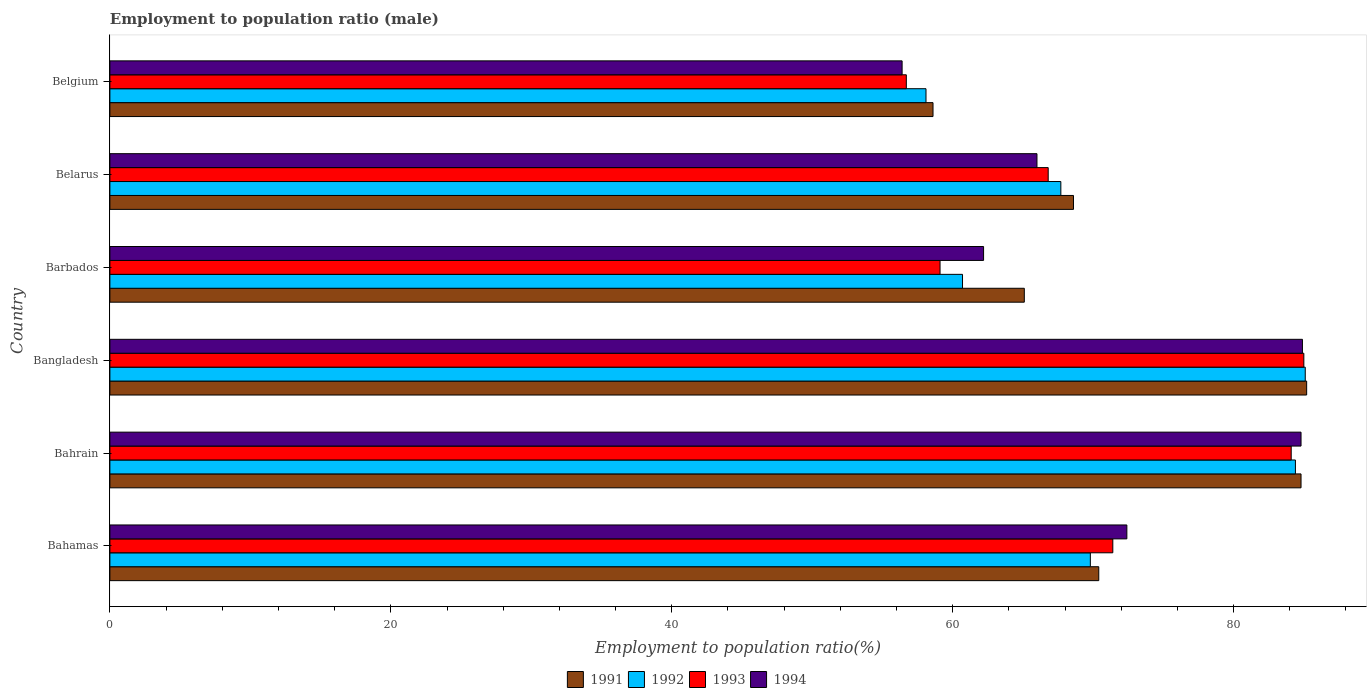How many groups of bars are there?
Provide a short and direct response. 6. Are the number of bars per tick equal to the number of legend labels?
Provide a succinct answer. Yes. How many bars are there on the 2nd tick from the top?
Provide a short and direct response. 4. What is the employment to population ratio in 1993 in Barbados?
Provide a short and direct response. 59.1. Across all countries, what is the maximum employment to population ratio in 1991?
Keep it short and to the point. 85.2. Across all countries, what is the minimum employment to population ratio in 1992?
Your response must be concise. 58.1. What is the total employment to population ratio in 1993 in the graph?
Your answer should be very brief. 423.1. What is the difference between the employment to population ratio in 1993 in Bahamas and that in Bahrain?
Provide a short and direct response. -12.7. What is the difference between the employment to population ratio in 1991 in Bahrain and the employment to population ratio in 1992 in Belgium?
Offer a very short reply. 26.7. What is the average employment to population ratio in 1993 per country?
Your answer should be compact. 70.52. What is the difference between the employment to population ratio in 1992 and employment to population ratio in 1993 in Belgium?
Provide a succinct answer. 1.4. In how many countries, is the employment to population ratio in 1991 greater than 32 %?
Provide a succinct answer. 6. What is the ratio of the employment to population ratio in 1992 in Bangladesh to that in Belgium?
Your answer should be very brief. 1.46. Is the employment to population ratio in 1991 in Bahamas less than that in Barbados?
Your answer should be very brief. No. Is the difference between the employment to population ratio in 1992 in Bahrain and Bangladesh greater than the difference between the employment to population ratio in 1993 in Bahrain and Bangladesh?
Make the answer very short. Yes. What is the difference between the highest and the second highest employment to population ratio in 1991?
Your answer should be very brief. 0.4. What is the difference between the highest and the lowest employment to population ratio in 1993?
Offer a very short reply. 28.3. In how many countries, is the employment to population ratio in 1991 greater than the average employment to population ratio in 1991 taken over all countries?
Provide a short and direct response. 2. Is it the case that in every country, the sum of the employment to population ratio in 1993 and employment to population ratio in 1991 is greater than the sum of employment to population ratio in 1992 and employment to population ratio in 1994?
Your response must be concise. No. What does the 1st bar from the top in Belgium represents?
Offer a terse response. 1994. What does the 2nd bar from the bottom in Belgium represents?
Your answer should be very brief. 1992. Is it the case that in every country, the sum of the employment to population ratio in 1994 and employment to population ratio in 1993 is greater than the employment to population ratio in 1992?
Offer a very short reply. Yes. How many bars are there?
Provide a succinct answer. 24. Does the graph contain any zero values?
Keep it short and to the point. No. Where does the legend appear in the graph?
Provide a succinct answer. Bottom center. How are the legend labels stacked?
Keep it short and to the point. Horizontal. What is the title of the graph?
Your response must be concise. Employment to population ratio (male). Does "1993" appear as one of the legend labels in the graph?
Your answer should be very brief. Yes. What is the label or title of the Y-axis?
Offer a terse response. Country. What is the Employment to population ratio(%) of 1991 in Bahamas?
Your response must be concise. 70.4. What is the Employment to population ratio(%) of 1992 in Bahamas?
Provide a short and direct response. 69.8. What is the Employment to population ratio(%) in 1993 in Bahamas?
Keep it short and to the point. 71.4. What is the Employment to population ratio(%) in 1994 in Bahamas?
Ensure brevity in your answer.  72.4. What is the Employment to population ratio(%) in 1991 in Bahrain?
Offer a very short reply. 84.8. What is the Employment to population ratio(%) in 1992 in Bahrain?
Your response must be concise. 84.4. What is the Employment to population ratio(%) of 1993 in Bahrain?
Your answer should be compact. 84.1. What is the Employment to population ratio(%) of 1994 in Bahrain?
Your answer should be compact. 84.8. What is the Employment to population ratio(%) of 1991 in Bangladesh?
Your response must be concise. 85.2. What is the Employment to population ratio(%) in 1992 in Bangladesh?
Offer a very short reply. 85.1. What is the Employment to population ratio(%) in 1994 in Bangladesh?
Give a very brief answer. 84.9. What is the Employment to population ratio(%) in 1991 in Barbados?
Your answer should be very brief. 65.1. What is the Employment to population ratio(%) in 1992 in Barbados?
Your answer should be very brief. 60.7. What is the Employment to population ratio(%) in 1993 in Barbados?
Your answer should be compact. 59.1. What is the Employment to population ratio(%) of 1994 in Barbados?
Provide a succinct answer. 62.2. What is the Employment to population ratio(%) in 1991 in Belarus?
Offer a very short reply. 68.6. What is the Employment to population ratio(%) of 1992 in Belarus?
Provide a succinct answer. 67.7. What is the Employment to population ratio(%) in 1993 in Belarus?
Make the answer very short. 66.8. What is the Employment to population ratio(%) of 1991 in Belgium?
Give a very brief answer. 58.6. What is the Employment to population ratio(%) of 1992 in Belgium?
Your answer should be very brief. 58.1. What is the Employment to population ratio(%) in 1993 in Belgium?
Offer a terse response. 56.7. What is the Employment to population ratio(%) of 1994 in Belgium?
Your answer should be very brief. 56.4. Across all countries, what is the maximum Employment to population ratio(%) in 1991?
Your response must be concise. 85.2. Across all countries, what is the maximum Employment to population ratio(%) in 1992?
Keep it short and to the point. 85.1. Across all countries, what is the maximum Employment to population ratio(%) in 1994?
Your response must be concise. 84.9. Across all countries, what is the minimum Employment to population ratio(%) in 1991?
Provide a succinct answer. 58.6. Across all countries, what is the minimum Employment to population ratio(%) in 1992?
Offer a terse response. 58.1. Across all countries, what is the minimum Employment to population ratio(%) of 1993?
Your answer should be very brief. 56.7. Across all countries, what is the minimum Employment to population ratio(%) in 1994?
Your answer should be very brief. 56.4. What is the total Employment to population ratio(%) in 1991 in the graph?
Keep it short and to the point. 432.7. What is the total Employment to population ratio(%) in 1992 in the graph?
Provide a succinct answer. 425.8. What is the total Employment to population ratio(%) in 1993 in the graph?
Provide a short and direct response. 423.1. What is the total Employment to population ratio(%) of 1994 in the graph?
Keep it short and to the point. 426.7. What is the difference between the Employment to population ratio(%) of 1991 in Bahamas and that in Bahrain?
Ensure brevity in your answer.  -14.4. What is the difference between the Employment to population ratio(%) of 1992 in Bahamas and that in Bahrain?
Provide a succinct answer. -14.6. What is the difference between the Employment to population ratio(%) of 1994 in Bahamas and that in Bahrain?
Keep it short and to the point. -12.4. What is the difference between the Employment to population ratio(%) of 1991 in Bahamas and that in Bangladesh?
Your response must be concise. -14.8. What is the difference between the Employment to population ratio(%) of 1992 in Bahamas and that in Bangladesh?
Your answer should be compact. -15.3. What is the difference between the Employment to population ratio(%) of 1991 in Bahamas and that in Barbados?
Offer a very short reply. 5.3. What is the difference between the Employment to population ratio(%) in 1992 in Bahamas and that in Barbados?
Your answer should be compact. 9.1. What is the difference between the Employment to population ratio(%) in 1994 in Bahamas and that in Barbados?
Give a very brief answer. 10.2. What is the difference between the Employment to population ratio(%) of 1991 in Bahamas and that in Belarus?
Your answer should be very brief. 1.8. What is the difference between the Employment to population ratio(%) in 1992 in Bahamas and that in Belarus?
Provide a short and direct response. 2.1. What is the difference between the Employment to population ratio(%) in 1994 in Bahamas and that in Belarus?
Make the answer very short. 6.4. What is the difference between the Employment to population ratio(%) in 1992 in Bahamas and that in Belgium?
Keep it short and to the point. 11.7. What is the difference between the Employment to population ratio(%) of 1993 in Bahamas and that in Belgium?
Make the answer very short. 14.7. What is the difference between the Employment to population ratio(%) of 1991 in Bahrain and that in Bangladesh?
Give a very brief answer. -0.4. What is the difference between the Employment to population ratio(%) of 1993 in Bahrain and that in Bangladesh?
Make the answer very short. -0.9. What is the difference between the Employment to population ratio(%) of 1994 in Bahrain and that in Bangladesh?
Your answer should be very brief. -0.1. What is the difference between the Employment to population ratio(%) in 1991 in Bahrain and that in Barbados?
Provide a succinct answer. 19.7. What is the difference between the Employment to population ratio(%) in 1992 in Bahrain and that in Barbados?
Your answer should be very brief. 23.7. What is the difference between the Employment to population ratio(%) of 1994 in Bahrain and that in Barbados?
Keep it short and to the point. 22.6. What is the difference between the Employment to population ratio(%) in 1991 in Bahrain and that in Belarus?
Offer a terse response. 16.2. What is the difference between the Employment to population ratio(%) in 1992 in Bahrain and that in Belarus?
Give a very brief answer. 16.7. What is the difference between the Employment to population ratio(%) in 1991 in Bahrain and that in Belgium?
Give a very brief answer. 26.2. What is the difference between the Employment to population ratio(%) of 1992 in Bahrain and that in Belgium?
Keep it short and to the point. 26.3. What is the difference between the Employment to population ratio(%) of 1993 in Bahrain and that in Belgium?
Keep it short and to the point. 27.4. What is the difference between the Employment to population ratio(%) in 1994 in Bahrain and that in Belgium?
Make the answer very short. 28.4. What is the difference between the Employment to population ratio(%) in 1991 in Bangladesh and that in Barbados?
Your answer should be very brief. 20.1. What is the difference between the Employment to population ratio(%) in 1992 in Bangladesh and that in Barbados?
Your response must be concise. 24.4. What is the difference between the Employment to population ratio(%) of 1993 in Bangladesh and that in Barbados?
Your response must be concise. 25.9. What is the difference between the Employment to population ratio(%) of 1994 in Bangladesh and that in Barbados?
Offer a very short reply. 22.7. What is the difference between the Employment to population ratio(%) in 1991 in Bangladesh and that in Belarus?
Keep it short and to the point. 16.6. What is the difference between the Employment to population ratio(%) of 1991 in Bangladesh and that in Belgium?
Make the answer very short. 26.6. What is the difference between the Employment to population ratio(%) of 1993 in Bangladesh and that in Belgium?
Your answer should be very brief. 28.3. What is the difference between the Employment to population ratio(%) in 1994 in Bangladesh and that in Belgium?
Your response must be concise. 28.5. What is the difference between the Employment to population ratio(%) of 1992 in Barbados and that in Belarus?
Provide a succinct answer. -7. What is the difference between the Employment to population ratio(%) of 1993 in Barbados and that in Belarus?
Provide a short and direct response. -7.7. What is the difference between the Employment to population ratio(%) in 1994 in Barbados and that in Belarus?
Ensure brevity in your answer.  -3.8. What is the difference between the Employment to population ratio(%) of 1993 in Barbados and that in Belgium?
Give a very brief answer. 2.4. What is the difference between the Employment to population ratio(%) in 1994 in Barbados and that in Belgium?
Your response must be concise. 5.8. What is the difference between the Employment to population ratio(%) of 1991 in Belarus and that in Belgium?
Make the answer very short. 10. What is the difference between the Employment to population ratio(%) in 1992 in Belarus and that in Belgium?
Provide a short and direct response. 9.6. What is the difference between the Employment to population ratio(%) of 1991 in Bahamas and the Employment to population ratio(%) of 1993 in Bahrain?
Provide a succinct answer. -13.7. What is the difference between the Employment to population ratio(%) of 1991 in Bahamas and the Employment to population ratio(%) of 1994 in Bahrain?
Give a very brief answer. -14.4. What is the difference between the Employment to population ratio(%) of 1992 in Bahamas and the Employment to population ratio(%) of 1993 in Bahrain?
Your response must be concise. -14.3. What is the difference between the Employment to population ratio(%) of 1992 in Bahamas and the Employment to population ratio(%) of 1994 in Bahrain?
Ensure brevity in your answer.  -15. What is the difference between the Employment to population ratio(%) of 1993 in Bahamas and the Employment to population ratio(%) of 1994 in Bahrain?
Your response must be concise. -13.4. What is the difference between the Employment to population ratio(%) in 1991 in Bahamas and the Employment to population ratio(%) in 1992 in Bangladesh?
Provide a short and direct response. -14.7. What is the difference between the Employment to population ratio(%) of 1991 in Bahamas and the Employment to population ratio(%) of 1993 in Bangladesh?
Your answer should be compact. -14.6. What is the difference between the Employment to population ratio(%) in 1992 in Bahamas and the Employment to population ratio(%) in 1993 in Bangladesh?
Offer a terse response. -15.2. What is the difference between the Employment to population ratio(%) in 1992 in Bahamas and the Employment to population ratio(%) in 1994 in Bangladesh?
Your answer should be compact. -15.1. What is the difference between the Employment to population ratio(%) of 1991 in Bahamas and the Employment to population ratio(%) of 1993 in Barbados?
Offer a terse response. 11.3. What is the difference between the Employment to population ratio(%) of 1992 in Bahamas and the Employment to population ratio(%) of 1994 in Barbados?
Offer a terse response. 7.6. What is the difference between the Employment to population ratio(%) of 1991 in Bahamas and the Employment to population ratio(%) of 1992 in Belarus?
Make the answer very short. 2.7. What is the difference between the Employment to population ratio(%) of 1992 in Bahamas and the Employment to population ratio(%) of 1993 in Belarus?
Provide a short and direct response. 3. What is the difference between the Employment to population ratio(%) in 1992 in Bahamas and the Employment to population ratio(%) in 1994 in Belarus?
Give a very brief answer. 3.8. What is the difference between the Employment to population ratio(%) in 1993 in Bahamas and the Employment to population ratio(%) in 1994 in Belarus?
Ensure brevity in your answer.  5.4. What is the difference between the Employment to population ratio(%) of 1991 in Bahamas and the Employment to population ratio(%) of 1993 in Belgium?
Ensure brevity in your answer.  13.7. What is the difference between the Employment to population ratio(%) of 1993 in Bahamas and the Employment to population ratio(%) of 1994 in Belgium?
Your response must be concise. 15. What is the difference between the Employment to population ratio(%) in 1991 in Bahrain and the Employment to population ratio(%) in 1993 in Bangladesh?
Offer a terse response. -0.2. What is the difference between the Employment to population ratio(%) in 1991 in Bahrain and the Employment to population ratio(%) in 1994 in Bangladesh?
Your response must be concise. -0.1. What is the difference between the Employment to population ratio(%) in 1992 in Bahrain and the Employment to population ratio(%) in 1993 in Bangladesh?
Your response must be concise. -0.6. What is the difference between the Employment to population ratio(%) of 1992 in Bahrain and the Employment to population ratio(%) of 1994 in Bangladesh?
Keep it short and to the point. -0.5. What is the difference between the Employment to population ratio(%) in 1993 in Bahrain and the Employment to population ratio(%) in 1994 in Bangladesh?
Offer a very short reply. -0.8. What is the difference between the Employment to population ratio(%) in 1991 in Bahrain and the Employment to population ratio(%) in 1992 in Barbados?
Provide a short and direct response. 24.1. What is the difference between the Employment to population ratio(%) of 1991 in Bahrain and the Employment to population ratio(%) of 1993 in Barbados?
Ensure brevity in your answer.  25.7. What is the difference between the Employment to population ratio(%) of 1991 in Bahrain and the Employment to population ratio(%) of 1994 in Barbados?
Offer a terse response. 22.6. What is the difference between the Employment to population ratio(%) of 1992 in Bahrain and the Employment to population ratio(%) of 1993 in Barbados?
Offer a very short reply. 25.3. What is the difference between the Employment to population ratio(%) of 1993 in Bahrain and the Employment to population ratio(%) of 1994 in Barbados?
Your answer should be compact. 21.9. What is the difference between the Employment to population ratio(%) of 1991 in Bahrain and the Employment to population ratio(%) of 1992 in Belarus?
Your answer should be compact. 17.1. What is the difference between the Employment to population ratio(%) in 1991 in Bahrain and the Employment to population ratio(%) in 1993 in Belarus?
Your response must be concise. 18. What is the difference between the Employment to population ratio(%) in 1991 in Bahrain and the Employment to population ratio(%) in 1994 in Belarus?
Keep it short and to the point. 18.8. What is the difference between the Employment to population ratio(%) in 1992 in Bahrain and the Employment to population ratio(%) in 1994 in Belarus?
Offer a terse response. 18.4. What is the difference between the Employment to population ratio(%) in 1993 in Bahrain and the Employment to population ratio(%) in 1994 in Belarus?
Offer a very short reply. 18.1. What is the difference between the Employment to population ratio(%) of 1991 in Bahrain and the Employment to population ratio(%) of 1992 in Belgium?
Your answer should be very brief. 26.7. What is the difference between the Employment to population ratio(%) in 1991 in Bahrain and the Employment to population ratio(%) in 1993 in Belgium?
Offer a very short reply. 28.1. What is the difference between the Employment to population ratio(%) of 1991 in Bahrain and the Employment to population ratio(%) of 1994 in Belgium?
Offer a terse response. 28.4. What is the difference between the Employment to population ratio(%) of 1992 in Bahrain and the Employment to population ratio(%) of 1993 in Belgium?
Your response must be concise. 27.7. What is the difference between the Employment to population ratio(%) in 1992 in Bahrain and the Employment to population ratio(%) in 1994 in Belgium?
Make the answer very short. 28. What is the difference between the Employment to population ratio(%) in 1993 in Bahrain and the Employment to population ratio(%) in 1994 in Belgium?
Make the answer very short. 27.7. What is the difference between the Employment to population ratio(%) of 1991 in Bangladesh and the Employment to population ratio(%) of 1992 in Barbados?
Offer a very short reply. 24.5. What is the difference between the Employment to population ratio(%) of 1991 in Bangladesh and the Employment to population ratio(%) of 1993 in Barbados?
Give a very brief answer. 26.1. What is the difference between the Employment to population ratio(%) in 1992 in Bangladesh and the Employment to population ratio(%) in 1993 in Barbados?
Your answer should be compact. 26. What is the difference between the Employment to population ratio(%) in 1992 in Bangladesh and the Employment to population ratio(%) in 1994 in Barbados?
Offer a very short reply. 22.9. What is the difference between the Employment to population ratio(%) in 1993 in Bangladesh and the Employment to population ratio(%) in 1994 in Barbados?
Ensure brevity in your answer.  22.8. What is the difference between the Employment to population ratio(%) in 1991 in Bangladesh and the Employment to population ratio(%) in 1992 in Belarus?
Make the answer very short. 17.5. What is the difference between the Employment to population ratio(%) of 1991 in Bangladesh and the Employment to population ratio(%) of 1993 in Belarus?
Offer a very short reply. 18.4. What is the difference between the Employment to population ratio(%) in 1991 in Bangladesh and the Employment to population ratio(%) in 1992 in Belgium?
Your answer should be very brief. 27.1. What is the difference between the Employment to population ratio(%) in 1991 in Bangladesh and the Employment to population ratio(%) in 1994 in Belgium?
Provide a short and direct response. 28.8. What is the difference between the Employment to population ratio(%) of 1992 in Bangladesh and the Employment to population ratio(%) of 1993 in Belgium?
Keep it short and to the point. 28.4. What is the difference between the Employment to population ratio(%) in 1992 in Bangladesh and the Employment to population ratio(%) in 1994 in Belgium?
Ensure brevity in your answer.  28.7. What is the difference between the Employment to population ratio(%) in 1993 in Bangladesh and the Employment to population ratio(%) in 1994 in Belgium?
Give a very brief answer. 28.6. What is the difference between the Employment to population ratio(%) of 1991 in Barbados and the Employment to population ratio(%) of 1994 in Belarus?
Keep it short and to the point. -0.9. What is the difference between the Employment to population ratio(%) of 1992 in Barbados and the Employment to population ratio(%) of 1993 in Belarus?
Give a very brief answer. -6.1. What is the difference between the Employment to population ratio(%) in 1992 in Barbados and the Employment to population ratio(%) in 1994 in Belarus?
Your answer should be compact. -5.3. What is the difference between the Employment to population ratio(%) in 1991 in Barbados and the Employment to population ratio(%) in 1992 in Belgium?
Make the answer very short. 7. What is the difference between the Employment to population ratio(%) in 1992 in Barbados and the Employment to population ratio(%) in 1993 in Belgium?
Make the answer very short. 4. What is the difference between the Employment to population ratio(%) of 1992 in Barbados and the Employment to population ratio(%) of 1994 in Belgium?
Your answer should be very brief. 4.3. What is the difference between the Employment to population ratio(%) in 1993 in Barbados and the Employment to population ratio(%) in 1994 in Belgium?
Your answer should be compact. 2.7. What is the difference between the Employment to population ratio(%) of 1991 in Belarus and the Employment to population ratio(%) of 1993 in Belgium?
Your answer should be very brief. 11.9. What is the difference between the Employment to population ratio(%) of 1991 in Belarus and the Employment to population ratio(%) of 1994 in Belgium?
Give a very brief answer. 12.2. What is the average Employment to population ratio(%) in 1991 per country?
Make the answer very short. 72.12. What is the average Employment to population ratio(%) in 1992 per country?
Provide a succinct answer. 70.97. What is the average Employment to population ratio(%) of 1993 per country?
Give a very brief answer. 70.52. What is the average Employment to population ratio(%) in 1994 per country?
Your response must be concise. 71.12. What is the difference between the Employment to population ratio(%) in 1991 and Employment to population ratio(%) in 1992 in Bahamas?
Make the answer very short. 0.6. What is the difference between the Employment to population ratio(%) in 1991 and Employment to population ratio(%) in 1993 in Bahamas?
Give a very brief answer. -1. What is the difference between the Employment to population ratio(%) of 1991 and Employment to population ratio(%) of 1994 in Bahamas?
Offer a terse response. -2. What is the difference between the Employment to population ratio(%) in 1993 and Employment to population ratio(%) in 1994 in Bahamas?
Offer a very short reply. -1. What is the difference between the Employment to population ratio(%) of 1993 and Employment to population ratio(%) of 1994 in Bahrain?
Make the answer very short. -0.7. What is the difference between the Employment to population ratio(%) in 1991 and Employment to population ratio(%) in 1992 in Bangladesh?
Make the answer very short. 0.1. What is the difference between the Employment to population ratio(%) of 1991 and Employment to population ratio(%) of 1994 in Bangladesh?
Provide a short and direct response. 0.3. What is the difference between the Employment to population ratio(%) of 1993 and Employment to population ratio(%) of 1994 in Bangladesh?
Your answer should be very brief. 0.1. What is the difference between the Employment to population ratio(%) in 1991 and Employment to population ratio(%) in 1993 in Barbados?
Keep it short and to the point. 6. What is the difference between the Employment to population ratio(%) of 1992 and Employment to population ratio(%) of 1993 in Barbados?
Your answer should be very brief. 1.6. What is the difference between the Employment to population ratio(%) of 1991 and Employment to population ratio(%) of 1993 in Belarus?
Your answer should be very brief. 1.8. What is the difference between the Employment to population ratio(%) of 1992 and Employment to population ratio(%) of 1994 in Belarus?
Your answer should be very brief. 1.7. What is the difference between the Employment to population ratio(%) in 1993 and Employment to population ratio(%) in 1994 in Belarus?
Your answer should be very brief. 0.8. What is the difference between the Employment to population ratio(%) in 1991 and Employment to population ratio(%) in 1993 in Belgium?
Keep it short and to the point. 1.9. What is the difference between the Employment to population ratio(%) of 1991 and Employment to population ratio(%) of 1994 in Belgium?
Make the answer very short. 2.2. What is the difference between the Employment to population ratio(%) in 1992 and Employment to population ratio(%) in 1993 in Belgium?
Your answer should be compact. 1.4. What is the difference between the Employment to population ratio(%) in 1992 and Employment to population ratio(%) in 1994 in Belgium?
Keep it short and to the point. 1.7. What is the ratio of the Employment to population ratio(%) in 1991 in Bahamas to that in Bahrain?
Give a very brief answer. 0.83. What is the ratio of the Employment to population ratio(%) of 1992 in Bahamas to that in Bahrain?
Give a very brief answer. 0.83. What is the ratio of the Employment to population ratio(%) of 1993 in Bahamas to that in Bahrain?
Provide a short and direct response. 0.85. What is the ratio of the Employment to population ratio(%) in 1994 in Bahamas to that in Bahrain?
Offer a very short reply. 0.85. What is the ratio of the Employment to population ratio(%) of 1991 in Bahamas to that in Bangladesh?
Provide a short and direct response. 0.83. What is the ratio of the Employment to population ratio(%) of 1992 in Bahamas to that in Bangladesh?
Make the answer very short. 0.82. What is the ratio of the Employment to population ratio(%) of 1993 in Bahamas to that in Bangladesh?
Ensure brevity in your answer.  0.84. What is the ratio of the Employment to population ratio(%) of 1994 in Bahamas to that in Bangladesh?
Provide a succinct answer. 0.85. What is the ratio of the Employment to population ratio(%) of 1991 in Bahamas to that in Barbados?
Make the answer very short. 1.08. What is the ratio of the Employment to population ratio(%) of 1992 in Bahamas to that in Barbados?
Provide a succinct answer. 1.15. What is the ratio of the Employment to population ratio(%) of 1993 in Bahamas to that in Barbados?
Offer a very short reply. 1.21. What is the ratio of the Employment to population ratio(%) of 1994 in Bahamas to that in Barbados?
Your response must be concise. 1.16. What is the ratio of the Employment to population ratio(%) of 1991 in Bahamas to that in Belarus?
Provide a succinct answer. 1.03. What is the ratio of the Employment to population ratio(%) in 1992 in Bahamas to that in Belarus?
Give a very brief answer. 1.03. What is the ratio of the Employment to population ratio(%) of 1993 in Bahamas to that in Belarus?
Offer a very short reply. 1.07. What is the ratio of the Employment to population ratio(%) of 1994 in Bahamas to that in Belarus?
Your answer should be compact. 1.1. What is the ratio of the Employment to population ratio(%) in 1991 in Bahamas to that in Belgium?
Offer a very short reply. 1.2. What is the ratio of the Employment to population ratio(%) in 1992 in Bahamas to that in Belgium?
Offer a very short reply. 1.2. What is the ratio of the Employment to population ratio(%) in 1993 in Bahamas to that in Belgium?
Your answer should be compact. 1.26. What is the ratio of the Employment to population ratio(%) of 1994 in Bahamas to that in Belgium?
Offer a very short reply. 1.28. What is the ratio of the Employment to population ratio(%) in 1991 in Bahrain to that in Bangladesh?
Ensure brevity in your answer.  1. What is the ratio of the Employment to population ratio(%) of 1993 in Bahrain to that in Bangladesh?
Keep it short and to the point. 0.99. What is the ratio of the Employment to population ratio(%) of 1991 in Bahrain to that in Barbados?
Keep it short and to the point. 1.3. What is the ratio of the Employment to population ratio(%) in 1992 in Bahrain to that in Barbados?
Provide a succinct answer. 1.39. What is the ratio of the Employment to population ratio(%) in 1993 in Bahrain to that in Barbados?
Make the answer very short. 1.42. What is the ratio of the Employment to population ratio(%) of 1994 in Bahrain to that in Barbados?
Your answer should be compact. 1.36. What is the ratio of the Employment to population ratio(%) in 1991 in Bahrain to that in Belarus?
Offer a terse response. 1.24. What is the ratio of the Employment to population ratio(%) in 1992 in Bahrain to that in Belarus?
Make the answer very short. 1.25. What is the ratio of the Employment to population ratio(%) in 1993 in Bahrain to that in Belarus?
Keep it short and to the point. 1.26. What is the ratio of the Employment to population ratio(%) in 1994 in Bahrain to that in Belarus?
Give a very brief answer. 1.28. What is the ratio of the Employment to population ratio(%) of 1991 in Bahrain to that in Belgium?
Your answer should be compact. 1.45. What is the ratio of the Employment to population ratio(%) in 1992 in Bahrain to that in Belgium?
Your answer should be compact. 1.45. What is the ratio of the Employment to population ratio(%) in 1993 in Bahrain to that in Belgium?
Offer a terse response. 1.48. What is the ratio of the Employment to population ratio(%) of 1994 in Bahrain to that in Belgium?
Provide a succinct answer. 1.5. What is the ratio of the Employment to population ratio(%) in 1991 in Bangladesh to that in Barbados?
Your answer should be compact. 1.31. What is the ratio of the Employment to population ratio(%) in 1992 in Bangladesh to that in Barbados?
Provide a short and direct response. 1.4. What is the ratio of the Employment to population ratio(%) in 1993 in Bangladesh to that in Barbados?
Your response must be concise. 1.44. What is the ratio of the Employment to population ratio(%) in 1994 in Bangladesh to that in Barbados?
Your answer should be very brief. 1.36. What is the ratio of the Employment to population ratio(%) of 1991 in Bangladesh to that in Belarus?
Give a very brief answer. 1.24. What is the ratio of the Employment to population ratio(%) in 1992 in Bangladesh to that in Belarus?
Offer a terse response. 1.26. What is the ratio of the Employment to population ratio(%) of 1993 in Bangladesh to that in Belarus?
Offer a very short reply. 1.27. What is the ratio of the Employment to population ratio(%) in 1994 in Bangladesh to that in Belarus?
Your response must be concise. 1.29. What is the ratio of the Employment to population ratio(%) in 1991 in Bangladesh to that in Belgium?
Give a very brief answer. 1.45. What is the ratio of the Employment to population ratio(%) of 1992 in Bangladesh to that in Belgium?
Your response must be concise. 1.46. What is the ratio of the Employment to population ratio(%) in 1993 in Bangladesh to that in Belgium?
Provide a succinct answer. 1.5. What is the ratio of the Employment to population ratio(%) of 1994 in Bangladesh to that in Belgium?
Your answer should be compact. 1.51. What is the ratio of the Employment to population ratio(%) in 1991 in Barbados to that in Belarus?
Make the answer very short. 0.95. What is the ratio of the Employment to population ratio(%) in 1992 in Barbados to that in Belarus?
Your answer should be compact. 0.9. What is the ratio of the Employment to population ratio(%) of 1993 in Barbados to that in Belarus?
Ensure brevity in your answer.  0.88. What is the ratio of the Employment to population ratio(%) in 1994 in Barbados to that in Belarus?
Offer a very short reply. 0.94. What is the ratio of the Employment to population ratio(%) of 1991 in Barbados to that in Belgium?
Your answer should be compact. 1.11. What is the ratio of the Employment to population ratio(%) of 1992 in Barbados to that in Belgium?
Offer a very short reply. 1.04. What is the ratio of the Employment to population ratio(%) in 1993 in Barbados to that in Belgium?
Your answer should be very brief. 1.04. What is the ratio of the Employment to population ratio(%) in 1994 in Barbados to that in Belgium?
Your response must be concise. 1.1. What is the ratio of the Employment to population ratio(%) in 1991 in Belarus to that in Belgium?
Ensure brevity in your answer.  1.17. What is the ratio of the Employment to population ratio(%) in 1992 in Belarus to that in Belgium?
Offer a very short reply. 1.17. What is the ratio of the Employment to population ratio(%) of 1993 in Belarus to that in Belgium?
Your response must be concise. 1.18. What is the ratio of the Employment to population ratio(%) in 1994 in Belarus to that in Belgium?
Your response must be concise. 1.17. What is the difference between the highest and the second highest Employment to population ratio(%) of 1991?
Your answer should be very brief. 0.4. What is the difference between the highest and the second highest Employment to population ratio(%) of 1993?
Your answer should be compact. 0.9. What is the difference between the highest and the lowest Employment to population ratio(%) in 1991?
Ensure brevity in your answer.  26.6. What is the difference between the highest and the lowest Employment to population ratio(%) of 1993?
Give a very brief answer. 28.3. 